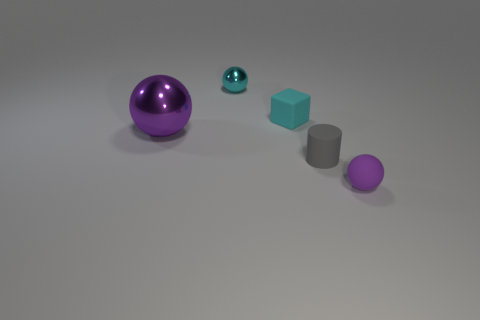Subtract all small rubber balls. How many balls are left? 2 Add 1 blue cubes. How many objects exist? 6 Subtract 2 spheres. How many spheres are left? 1 Subtract all blue cylinders. How many purple balls are left? 2 Subtract all cubes. How many objects are left? 4 Subtract all cyan spheres. How many spheres are left? 2 Subtract all cyan balls. Subtract all small matte cylinders. How many objects are left? 3 Add 2 small cyan matte things. How many small cyan matte things are left? 3 Add 3 big green rubber cubes. How many big green rubber cubes exist? 3 Subtract 0 brown cubes. How many objects are left? 5 